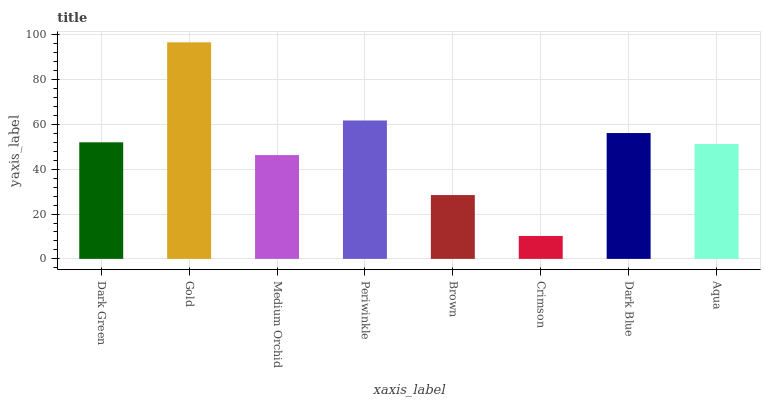Is Crimson the minimum?
Answer yes or no. Yes. Is Gold the maximum?
Answer yes or no. Yes. Is Medium Orchid the minimum?
Answer yes or no. No. Is Medium Orchid the maximum?
Answer yes or no. No. Is Gold greater than Medium Orchid?
Answer yes or no. Yes. Is Medium Orchid less than Gold?
Answer yes or no. Yes. Is Medium Orchid greater than Gold?
Answer yes or no. No. Is Gold less than Medium Orchid?
Answer yes or no. No. Is Dark Green the high median?
Answer yes or no. Yes. Is Aqua the low median?
Answer yes or no. Yes. Is Brown the high median?
Answer yes or no. No. Is Brown the low median?
Answer yes or no. No. 